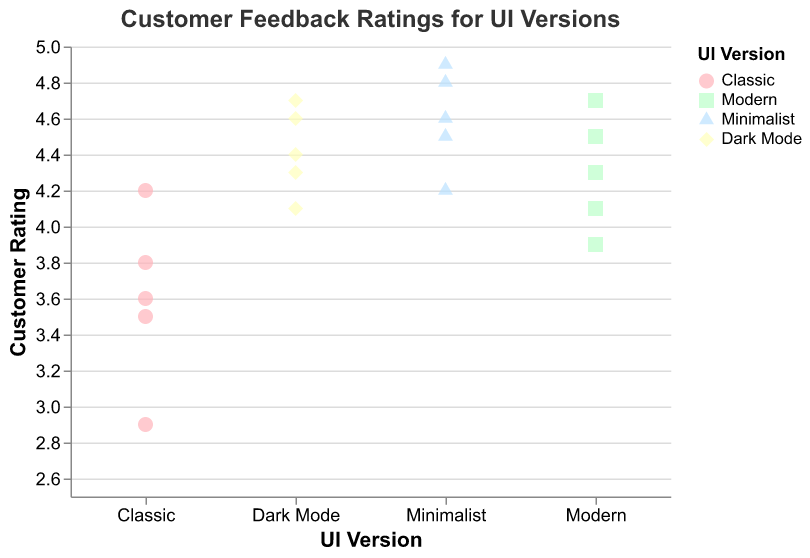What is the title of the chart? The title of the chart is displayed at the top of the figure and reads "Customer Feedback Ratings for UI Versions".
Answer: Customer Feedback Ratings for UI Versions What is the minimum rating observed for the 'Classic' UI version? By observing the 'Classic' group on the y-axis, the lowest data point (rating) appears at 2.9.
Answer: 2.9 Which UI version has the highest single customer rating? By comparing the highest data points in each UI version group, 'Minimalist' has the highest single rating of 4.9.
Answer: Minimalist How do the average ratings for 'Modern' and 'Dark Mode' compare? Calculate the average for 'Modern' (4.1, 4.5, 3.9, 4.3, 4.7) which sums to 21.5; the average is 21.5/5 = 4.3. Calculate the average for 'Dark Mode' (4.3, 4.7, 4.1, 4.4, 4.6) which sums to 22.1; the average is 22.1/5 = 4.42. 'Dark Mode' has a slightly higher average rating.
Answer: Dark Mode What color is used to represent the 'Minimalist' UI version? The color legend for UI Versions shows 'Minimalist' represented by a light blue color.
Answer: Light blue How many data points are there for the 'Modern' UI version? By counting the number of points under the 'Modern' UI column, there are 5 data points.
Answer: 5 Which UI version shows the most consistent set of customer ratings? The most consistent set of ratings can be identified by observing the spread of data points. 'Minimalist' has ratings closely clustered around the 4.5 to 4.9 range, indicating high consistency.
Answer: Minimalist Between 'Classic' and 'Modern' UI versions, which has a higher range of customer ratings? The range is calculated by subtracting the lowest rating from the highest rating in each UI version. For 'Classic', the range is 4.2 - 2.9 = 1.3. For 'Modern', the range is 4.7 - 3.9 = 0.8. 'Classic' has a higher range of customer ratings.
Answer: Classic 